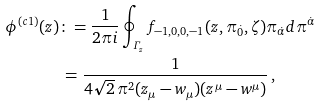<formula> <loc_0><loc_0><loc_500><loc_500>\phi ^ { ( c 1 ) } ( z ) & \colon = \frac { 1 } { 2 \pi i } \oint _ { \varGamma _ { z } } f _ { - 1 , 0 , 0 , - 1 } ( z , \pi _ { \dot { 0 } } , \zeta ) \pi _ { \dot { \alpha } } d \pi ^ { \dot { \alpha } } \\ & \, = \frac { 1 } { 4 \sqrt { 2 } \, \pi ^ { 2 } ( z _ { \mu } - w _ { \mu } ) ( z ^ { \mu } - w ^ { \mu } ) } \, ,</formula> 